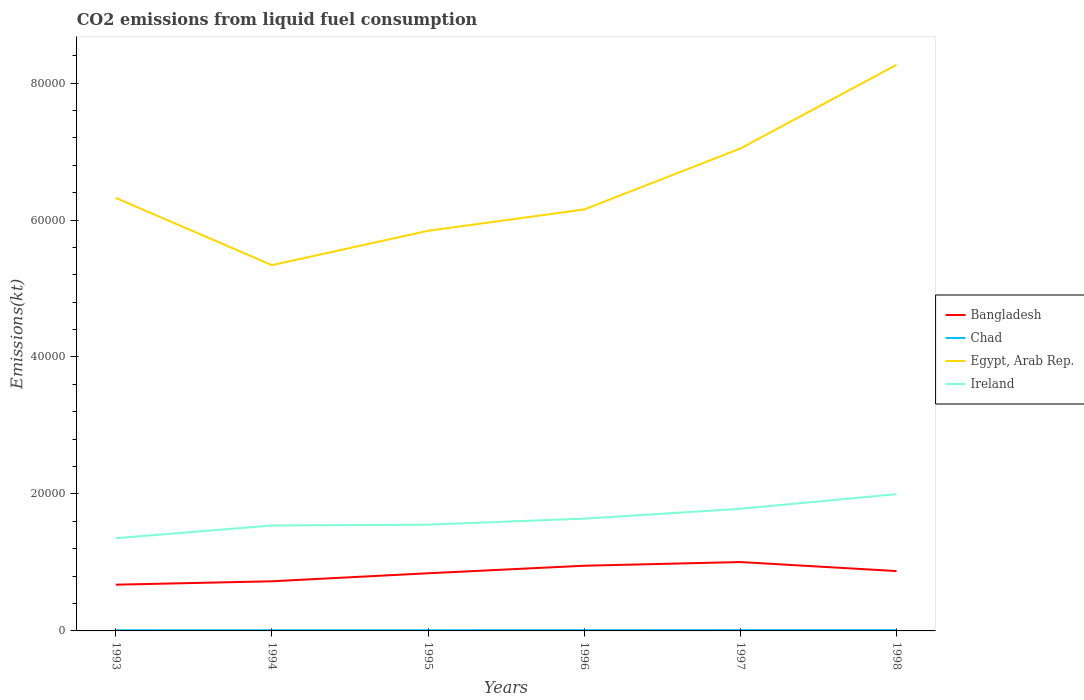How many different coloured lines are there?
Provide a succinct answer. 4. Does the line corresponding to Ireland intersect with the line corresponding to Chad?
Your answer should be compact. No. Across all years, what is the maximum amount of CO2 emitted in Chad?
Give a very brief answer. 99.01. In which year was the amount of CO2 emitted in Ireland maximum?
Offer a very short reply. 1993. What is the total amount of CO2 emitted in Ireland in the graph?
Your answer should be compact. -1001.09. What is the difference between the highest and the second highest amount of CO2 emitted in Ireland?
Make the answer very short. 6431.92. What is the difference between the highest and the lowest amount of CO2 emitted in Ireland?
Provide a short and direct response. 2. Is the amount of CO2 emitted in Chad strictly greater than the amount of CO2 emitted in Egypt, Arab Rep. over the years?
Offer a very short reply. Yes. How many lines are there?
Your response must be concise. 4. What is the difference between two consecutive major ticks on the Y-axis?
Ensure brevity in your answer.  2.00e+04. Does the graph contain any zero values?
Offer a terse response. No. Where does the legend appear in the graph?
Keep it short and to the point. Center right. How many legend labels are there?
Make the answer very short. 4. How are the legend labels stacked?
Make the answer very short. Vertical. What is the title of the graph?
Ensure brevity in your answer.  CO2 emissions from liquid fuel consumption. Does "Nepal" appear as one of the legend labels in the graph?
Provide a succinct answer. No. What is the label or title of the X-axis?
Offer a very short reply. Years. What is the label or title of the Y-axis?
Make the answer very short. Emissions(kt). What is the Emissions(kt) in Bangladesh in 1993?
Ensure brevity in your answer.  6750.95. What is the Emissions(kt) in Chad in 1993?
Provide a short and direct response. 99.01. What is the Emissions(kt) of Egypt, Arab Rep. in 1993?
Provide a short and direct response. 6.32e+04. What is the Emissions(kt) in Ireland in 1993?
Offer a very short reply. 1.35e+04. What is the Emissions(kt) of Bangladesh in 1994?
Give a very brief answer. 7249.66. What is the Emissions(kt) of Chad in 1994?
Provide a short and direct response. 102.68. What is the Emissions(kt) in Egypt, Arab Rep. in 1994?
Make the answer very short. 5.34e+04. What is the Emissions(kt) of Ireland in 1994?
Your response must be concise. 1.54e+04. What is the Emissions(kt) in Bangladesh in 1995?
Your answer should be very brief. 8419.43. What is the Emissions(kt) in Chad in 1995?
Give a very brief answer. 102.68. What is the Emissions(kt) of Egypt, Arab Rep. in 1995?
Your answer should be very brief. 5.84e+04. What is the Emissions(kt) of Ireland in 1995?
Your response must be concise. 1.55e+04. What is the Emissions(kt) in Bangladesh in 1996?
Offer a terse response. 9519.53. What is the Emissions(kt) of Chad in 1996?
Provide a succinct answer. 106.34. What is the Emissions(kt) of Egypt, Arab Rep. in 1996?
Your answer should be compact. 6.15e+04. What is the Emissions(kt) in Ireland in 1996?
Offer a very short reply. 1.64e+04. What is the Emissions(kt) of Bangladesh in 1997?
Keep it short and to the point. 1.01e+04. What is the Emissions(kt) in Chad in 1997?
Offer a very short reply. 113.68. What is the Emissions(kt) in Egypt, Arab Rep. in 1997?
Make the answer very short. 7.04e+04. What is the Emissions(kt) in Ireland in 1997?
Give a very brief answer. 1.78e+04. What is the Emissions(kt) in Bangladesh in 1998?
Offer a very short reply. 8738.46. What is the Emissions(kt) in Chad in 1998?
Give a very brief answer. 113.68. What is the Emissions(kt) in Egypt, Arab Rep. in 1998?
Your answer should be very brief. 8.27e+04. What is the Emissions(kt) in Ireland in 1998?
Offer a very short reply. 2.00e+04. Across all years, what is the maximum Emissions(kt) of Bangladesh?
Provide a short and direct response. 1.01e+04. Across all years, what is the maximum Emissions(kt) of Chad?
Provide a short and direct response. 113.68. Across all years, what is the maximum Emissions(kt) in Egypt, Arab Rep.?
Offer a terse response. 8.27e+04. Across all years, what is the maximum Emissions(kt) in Ireland?
Provide a short and direct response. 2.00e+04. Across all years, what is the minimum Emissions(kt) of Bangladesh?
Your answer should be very brief. 6750.95. Across all years, what is the minimum Emissions(kt) of Chad?
Your answer should be very brief. 99.01. Across all years, what is the minimum Emissions(kt) in Egypt, Arab Rep.?
Make the answer very short. 5.34e+04. Across all years, what is the minimum Emissions(kt) of Ireland?
Keep it short and to the point. 1.35e+04. What is the total Emissions(kt) of Bangladesh in the graph?
Give a very brief answer. 5.07e+04. What is the total Emissions(kt) of Chad in the graph?
Make the answer very short. 638.06. What is the total Emissions(kt) of Egypt, Arab Rep. in the graph?
Make the answer very short. 3.90e+05. What is the total Emissions(kt) in Ireland in the graph?
Keep it short and to the point. 9.86e+04. What is the difference between the Emissions(kt) of Bangladesh in 1993 and that in 1994?
Your response must be concise. -498.71. What is the difference between the Emissions(kt) in Chad in 1993 and that in 1994?
Your response must be concise. -3.67. What is the difference between the Emissions(kt) of Egypt, Arab Rep. in 1993 and that in 1994?
Offer a very short reply. 9820.23. What is the difference between the Emissions(kt) in Ireland in 1993 and that in 1994?
Provide a short and direct response. -1855.5. What is the difference between the Emissions(kt) in Bangladesh in 1993 and that in 1995?
Give a very brief answer. -1668.48. What is the difference between the Emissions(kt) in Chad in 1993 and that in 1995?
Keep it short and to the point. -3.67. What is the difference between the Emissions(kt) of Egypt, Arab Rep. in 1993 and that in 1995?
Ensure brevity in your answer.  4807.44. What is the difference between the Emissions(kt) in Ireland in 1993 and that in 1995?
Provide a succinct answer. -1976.51. What is the difference between the Emissions(kt) of Bangladesh in 1993 and that in 1996?
Your answer should be very brief. -2768.59. What is the difference between the Emissions(kt) of Chad in 1993 and that in 1996?
Your response must be concise. -7.33. What is the difference between the Emissions(kt) of Egypt, Arab Rep. in 1993 and that in 1996?
Your response must be concise. 1690.49. What is the difference between the Emissions(kt) in Ireland in 1993 and that in 1996?
Offer a very short reply. -2856.59. What is the difference between the Emissions(kt) of Bangladesh in 1993 and that in 1997?
Offer a terse response. -3307.63. What is the difference between the Emissions(kt) in Chad in 1993 and that in 1997?
Make the answer very short. -14.67. What is the difference between the Emissions(kt) in Egypt, Arab Rep. in 1993 and that in 1997?
Give a very brief answer. -7205.65. What is the difference between the Emissions(kt) of Ireland in 1993 and that in 1997?
Make the answer very short. -4297.72. What is the difference between the Emissions(kt) in Bangladesh in 1993 and that in 1998?
Offer a terse response. -1987.51. What is the difference between the Emissions(kt) in Chad in 1993 and that in 1998?
Offer a very short reply. -14.67. What is the difference between the Emissions(kt) in Egypt, Arab Rep. in 1993 and that in 1998?
Your answer should be compact. -1.94e+04. What is the difference between the Emissions(kt) of Ireland in 1993 and that in 1998?
Ensure brevity in your answer.  -6431.92. What is the difference between the Emissions(kt) of Bangladesh in 1994 and that in 1995?
Make the answer very short. -1169.77. What is the difference between the Emissions(kt) in Chad in 1994 and that in 1995?
Offer a very short reply. 0. What is the difference between the Emissions(kt) of Egypt, Arab Rep. in 1994 and that in 1995?
Provide a succinct answer. -5012.79. What is the difference between the Emissions(kt) of Ireland in 1994 and that in 1995?
Provide a short and direct response. -121.01. What is the difference between the Emissions(kt) in Bangladesh in 1994 and that in 1996?
Your response must be concise. -2269.87. What is the difference between the Emissions(kt) of Chad in 1994 and that in 1996?
Provide a succinct answer. -3.67. What is the difference between the Emissions(kt) of Egypt, Arab Rep. in 1994 and that in 1996?
Provide a succinct answer. -8129.74. What is the difference between the Emissions(kt) of Ireland in 1994 and that in 1996?
Provide a short and direct response. -1001.09. What is the difference between the Emissions(kt) of Bangladesh in 1994 and that in 1997?
Provide a short and direct response. -2808.92. What is the difference between the Emissions(kt) in Chad in 1994 and that in 1997?
Provide a short and direct response. -11. What is the difference between the Emissions(kt) of Egypt, Arab Rep. in 1994 and that in 1997?
Offer a terse response. -1.70e+04. What is the difference between the Emissions(kt) of Ireland in 1994 and that in 1997?
Give a very brief answer. -2442.22. What is the difference between the Emissions(kt) of Bangladesh in 1994 and that in 1998?
Keep it short and to the point. -1488.8. What is the difference between the Emissions(kt) of Chad in 1994 and that in 1998?
Provide a short and direct response. -11. What is the difference between the Emissions(kt) in Egypt, Arab Rep. in 1994 and that in 1998?
Offer a terse response. -2.92e+04. What is the difference between the Emissions(kt) of Ireland in 1994 and that in 1998?
Your response must be concise. -4576.42. What is the difference between the Emissions(kt) of Bangladesh in 1995 and that in 1996?
Keep it short and to the point. -1100.1. What is the difference between the Emissions(kt) of Chad in 1995 and that in 1996?
Ensure brevity in your answer.  -3.67. What is the difference between the Emissions(kt) of Egypt, Arab Rep. in 1995 and that in 1996?
Ensure brevity in your answer.  -3116.95. What is the difference between the Emissions(kt) in Ireland in 1995 and that in 1996?
Give a very brief answer. -880.08. What is the difference between the Emissions(kt) of Bangladesh in 1995 and that in 1997?
Offer a terse response. -1639.15. What is the difference between the Emissions(kt) in Chad in 1995 and that in 1997?
Your response must be concise. -11. What is the difference between the Emissions(kt) of Egypt, Arab Rep. in 1995 and that in 1997?
Keep it short and to the point. -1.20e+04. What is the difference between the Emissions(kt) of Ireland in 1995 and that in 1997?
Your answer should be very brief. -2321.21. What is the difference between the Emissions(kt) of Bangladesh in 1995 and that in 1998?
Keep it short and to the point. -319.03. What is the difference between the Emissions(kt) of Chad in 1995 and that in 1998?
Keep it short and to the point. -11. What is the difference between the Emissions(kt) in Egypt, Arab Rep. in 1995 and that in 1998?
Ensure brevity in your answer.  -2.42e+04. What is the difference between the Emissions(kt) in Ireland in 1995 and that in 1998?
Provide a short and direct response. -4455.4. What is the difference between the Emissions(kt) in Bangladesh in 1996 and that in 1997?
Your response must be concise. -539.05. What is the difference between the Emissions(kt) of Chad in 1996 and that in 1997?
Your answer should be very brief. -7.33. What is the difference between the Emissions(kt) of Egypt, Arab Rep. in 1996 and that in 1997?
Make the answer very short. -8896.14. What is the difference between the Emissions(kt) in Ireland in 1996 and that in 1997?
Offer a terse response. -1441.13. What is the difference between the Emissions(kt) of Bangladesh in 1996 and that in 1998?
Your answer should be very brief. 781.07. What is the difference between the Emissions(kt) of Chad in 1996 and that in 1998?
Keep it short and to the point. -7.33. What is the difference between the Emissions(kt) of Egypt, Arab Rep. in 1996 and that in 1998?
Offer a very short reply. -2.11e+04. What is the difference between the Emissions(kt) in Ireland in 1996 and that in 1998?
Ensure brevity in your answer.  -3575.32. What is the difference between the Emissions(kt) in Bangladesh in 1997 and that in 1998?
Offer a very short reply. 1320.12. What is the difference between the Emissions(kt) in Chad in 1997 and that in 1998?
Your answer should be compact. 0. What is the difference between the Emissions(kt) of Egypt, Arab Rep. in 1997 and that in 1998?
Keep it short and to the point. -1.22e+04. What is the difference between the Emissions(kt) of Ireland in 1997 and that in 1998?
Offer a terse response. -2134.19. What is the difference between the Emissions(kt) of Bangladesh in 1993 and the Emissions(kt) of Chad in 1994?
Keep it short and to the point. 6648.27. What is the difference between the Emissions(kt) in Bangladesh in 1993 and the Emissions(kt) in Egypt, Arab Rep. in 1994?
Make the answer very short. -4.67e+04. What is the difference between the Emissions(kt) in Bangladesh in 1993 and the Emissions(kt) in Ireland in 1994?
Keep it short and to the point. -8643.12. What is the difference between the Emissions(kt) in Chad in 1993 and the Emissions(kt) in Egypt, Arab Rep. in 1994?
Give a very brief answer. -5.33e+04. What is the difference between the Emissions(kt) of Chad in 1993 and the Emissions(kt) of Ireland in 1994?
Offer a terse response. -1.53e+04. What is the difference between the Emissions(kt) of Egypt, Arab Rep. in 1993 and the Emissions(kt) of Ireland in 1994?
Provide a succinct answer. 4.78e+04. What is the difference between the Emissions(kt) of Bangladesh in 1993 and the Emissions(kt) of Chad in 1995?
Make the answer very short. 6648.27. What is the difference between the Emissions(kt) in Bangladesh in 1993 and the Emissions(kt) in Egypt, Arab Rep. in 1995?
Provide a succinct answer. -5.17e+04. What is the difference between the Emissions(kt) in Bangladesh in 1993 and the Emissions(kt) in Ireland in 1995?
Provide a succinct answer. -8764.13. What is the difference between the Emissions(kt) of Chad in 1993 and the Emissions(kt) of Egypt, Arab Rep. in 1995?
Ensure brevity in your answer.  -5.83e+04. What is the difference between the Emissions(kt) of Chad in 1993 and the Emissions(kt) of Ireland in 1995?
Provide a short and direct response. -1.54e+04. What is the difference between the Emissions(kt) in Egypt, Arab Rep. in 1993 and the Emissions(kt) in Ireland in 1995?
Provide a succinct answer. 4.77e+04. What is the difference between the Emissions(kt) in Bangladesh in 1993 and the Emissions(kt) in Chad in 1996?
Your answer should be compact. 6644.6. What is the difference between the Emissions(kt) of Bangladesh in 1993 and the Emissions(kt) of Egypt, Arab Rep. in 1996?
Your answer should be very brief. -5.48e+04. What is the difference between the Emissions(kt) in Bangladesh in 1993 and the Emissions(kt) in Ireland in 1996?
Keep it short and to the point. -9644.21. What is the difference between the Emissions(kt) in Chad in 1993 and the Emissions(kt) in Egypt, Arab Rep. in 1996?
Keep it short and to the point. -6.14e+04. What is the difference between the Emissions(kt) in Chad in 1993 and the Emissions(kt) in Ireland in 1996?
Ensure brevity in your answer.  -1.63e+04. What is the difference between the Emissions(kt) of Egypt, Arab Rep. in 1993 and the Emissions(kt) of Ireland in 1996?
Ensure brevity in your answer.  4.68e+04. What is the difference between the Emissions(kt) of Bangladesh in 1993 and the Emissions(kt) of Chad in 1997?
Keep it short and to the point. 6637.27. What is the difference between the Emissions(kt) in Bangladesh in 1993 and the Emissions(kt) in Egypt, Arab Rep. in 1997?
Keep it short and to the point. -6.37e+04. What is the difference between the Emissions(kt) of Bangladesh in 1993 and the Emissions(kt) of Ireland in 1997?
Offer a terse response. -1.11e+04. What is the difference between the Emissions(kt) of Chad in 1993 and the Emissions(kt) of Egypt, Arab Rep. in 1997?
Your response must be concise. -7.03e+04. What is the difference between the Emissions(kt) of Chad in 1993 and the Emissions(kt) of Ireland in 1997?
Keep it short and to the point. -1.77e+04. What is the difference between the Emissions(kt) of Egypt, Arab Rep. in 1993 and the Emissions(kt) of Ireland in 1997?
Give a very brief answer. 4.54e+04. What is the difference between the Emissions(kt) in Bangladesh in 1993 and the Emissions(kt) in Chad in 1998?
Provide a short and direct response. 6637.27. What is the difference between the Emissions(kt) in Bangladesh in 1993 and the Emissions(kt) in Egypt, Arab Rep. in 1998?
Offer a terse response. -7.59e+04. What is the difference between the Emissions(kt) of Bangladesh in 1993 and the Emissions(kt) of Ireland in 1998?
Provide a succinct answer. -1.32e+04. What is the difference between the Emissions(kt) in Chad in 1993 and the Emissions(kt) in Egypt, Arab Rep. in 1998?
Provide a succinct answer. -8.26e+04. What is the difference between the Emissions(kt) of Chad in 1993 and the Emissions(kt) of Ireland in 1998?
Provide a short and direct response. -1.99e+04. What is the difference between the Emissions(kt) of Egypt, Arab Rep. in 1993 and the Emissions(kt) of Ireland in 1998?
Make the answer very short. 4.33e+04. What is the difference between the Emissions(kt) of Bangladesh in 1994 and the Emissions(kt) of Chad in 1995?
Provide a succinct answer. 7146.98. What is the difference between the Emissions(kt) of Bangladesh in 1994 and the Emissions(kt) of Egypt, Arab Rep. in 1995?
Offer a very short reply. -5.12e+04. What is the difference between the Emissions(kt) in Bangladesh in 1994 and the Emissions(kt) in Ireland in 1995?
Your response must be concise. -8265.42. What is the difference between the Emissions(kt) in Chad in 1994 and the Emissions(kt) in Egypt, Arab Rep. in 1995?
Keep it short and to the point. -5.83e+04. What is the difference between the Emissions(kt) of Chad in 1994 and the Emissions(kt) of Ireland in 1995?
Provide a short and direct response. -1.54e+04. What is the difference between the Emissions(kt) of Egypt, Arab Rep. in 1994 and the Emissions(kt) of Ireland in 1995?
Offer a very short reply. 3.79e+04. What is the difference between the Emissions(kt) of Bangladesh in 1994 and the Emissions(kt) of Chad in 1996?
Your response must be concise. 7143.32. What is the difference between the Emissions(kt) in Bangladesh in 1994 and the Emissions(kt) in Egypt, Arab Rep. in 1996?
Keep it short and to the point. -5.43e+04. What is the difference between the Emissions(kt) in Bangladesh in 1994 and the Emissions(kt) in Ireland in 1996?
Your response must be concise. -9145.5. What is the difference between the Emissions(kt) of Chad in 1994 and the Emissions(kt) of Egypt, Arab Rep. in 1996?
Provide a short and direct response. -6.14e+04. What is the difference between the Emissions(kt) in Chad in 1994 and the Emissions(kt) in Ireland in 1996?
Make the answer very short. -1.63e+04. What is the difference between the Emissions(kt) in Egypt, Arab Rep. in 1994 and the Emissions(kt) in Ireland in 1996?
Make the answer very short. 3.70e+04. What is the difference between the Emissions(kt) in Bangladesh in 1994 and the Emissions(kt) in Chad in 1997?
Make the answer very short. 7135.98. What is the difference between the Emissions(kt) in Bangladesh in 1994 and the Emissions(kt) in Egypt, Arab Rep. in 1997?
Keep it short and to the point. -6.32e+04. What is the difference between the Emissions(kt) in Bangladesh in 1994 and the Emissions(kt) in Ireland in 1997?
Ensure brevity in your answer.  -1.06e+04. What is the difference between the Emissions(kt) in Chad in 1994 and the Emissions(kt) in Egypt, Arab Rep. in 1997?
Give a very brief answer. -7.03e+04. What is the difference between the Emissions(kt) in Chad in 1994 and the Emissions(kt) in Ireland in 1997?
Your answer should be compact. -1.77e+04. What is the difference between the Emissions(kt) of Egypt, Arab Rep. in 1994 and the Emissions(kt) of Ireland in 1997?
Your response must be concise. 3.56e+04. What is the difference between the Emissions(kt) of Bangladesh in 1994 and the Emissions(kt) of Chad in 1998?
Your answer should be very brief. 7135.98. What is the difference between the Emissions(kt) in Bangladesh in 1994 and the Emissions(kt) in Egypt, Arab Rep. in 1998?
Provide a short and direct response. -7.54e+04. What is the difference between the Emissions(kt) of Bangladesh in 1994 and the Emissions(kt) of Ireland in 1998?
Keep it short and to the point. -1.27e+04. What is the difference between the Emissions(kt) of Chad in 1994 and the Emissions(kt) of Egypt, Arab Rep. in 1998?
Your answer should be compact. -8.26e+04. What is the difference between the Emissions(kt) of Chad in 1994 and the Emissions(kt) of Ireland in 1998?
Offer a terse response. -1.99e+04. What is the difference between the Emissions(kt) of Egypt, Arab Rep. in 1994 and the Emissions(kt) of Ireland in 1998?
Provide a succinct answer. 3.34e+04. What is the difference between the Emissions(kt) of Bangladesh in 1995 and the Emissions(kt) of Chad in 1996?
Give a very brief answer. 8313.09. What is the difference between the Emissions(kt) in Bangladesh in 1995 and the Emissions(kt) in Egypt, Arab Rep. in 1996?
Ensure brevity in your answer.  -5.31e+04. What is the difference between the Emissions(kt) in Bangladesh in 1995 and the Emissions(kt) in Ireland in 1996?
Ensure brevity in your answer.  -7975.73. What is the difference between the Emissions(kt) in Chad in 1995 and the Emissions(kt) in Egypt, Arab Rep. in 1996?
Give a very brief answer. -6.14e+04. What is the difference between the Emissions(kt) of Chad in 1995 and the Emissions(kt) of Ireland in 1996?
Give a very brief answer. -1.63e+04. What is the difference between the Emissions(kt) in Egypt, Arab Rep. in 1995 and the Emissions(kt) in Ireland in 1996?
Provide a succinct answer. 4.20e+04. What is the difference between the Emissions(kt) in Bangladesh in 1995 and the Emissions(kt) in Chad in 1997?
Make the answer very short. 8305.75. What is the difference between the Emissions(kt) in Bangladesh in 1995 and the Emissions(kt) in Egypt, Arab Rep. in 1997?
Keep it short and to the point. -6.20e+04. What is the difference between the Emissions(kt) in Bangladesh in 1995 and the Emissions(kt) in Ireland in 1997?
Offer a terse response. -9416.86. What is the difference between the Emissions(kt) in Chad in 1995 and the Emissions(kt) in Egypt, Arab Rep. in 1997?
Ensure brevity in your answer.  -7.03e+04. What is the difference between the Emissions(kt) in Chad in 1995 and the Emissions(kt) in Ireland in 1997?
Give a very brief answer. -1.77e+04. What is the difference between the Emissions(kt) in Egypt, Arab Rep. in 1995 and the Emissions(kt) in Ireland in 1997?
Provide a succinct answer. 4.06e+04. What is the difference between the Emissions(kt) of Bangladesh in 1995 and the Emissions(kt) of Chad in 1998?
Provide a short and direct response. 8305.75. What is the difference between the Emissions(kt) in Bangladesh in 1995 and the Emissions(kt) in Egypt, Arab Rep. in 1998?
Offer a terse response. -7.42e+04. What is the difference between the Emissions(kt) in Bangladesh in 1995 and the Emissions(kt) in Ireland in 1998?
Your answer should be compact. -1.16e+04. What is the difference between the Emissions(kt) in Chad in 1995 and the Emissions(kt) in Egypt, Arab Rep. in 1998?
Your answer should be very brief. -8.26e+04. What is the difference between the Emissions(kt) of Chad in 1995 and the Emissions(kt) of Ireland in 1998?
Your answer should be compact. -1.99e+04. What is the difference between the Emissions(kt) of Egypt, Arab Rep. in 1995 and the Emissions(kt) of Ireland in 1998?
Ensure brevity in your answer.  3.85e+04. What is the difference between the Emissions(kt) in Bangladesh in 1996 and the Emissions(kt) in Chad in 1997?
Keep it short and to the point. 9405.85. What is the difference between the Emissions(kt) in Bangladesh in 1996 and the Emissions(kt) in Egypt, Arab Rep. in 1997?
Offer a terse response. -6.09e+04. What is the difference between the Emissions(kt) in Bangladesh in 1996 and the Emissions(kt) in Ireland in 1997?
Give a very brief answer. -8316.76. What is the difference between the Emissions(kt) in Chad in 1996 and the Emissions(kt) in Egypt, Arab Rep. in 1997?
Ensure brevity in your answer.  -7.03e+04. What is the difference between the Emissions(kt) of Chad in 1996 and the Emissions(kt) of Ireland in 1997?
Give a very brief answer. -1.77e+04. What is the difference between the Emissions(kt) of Egypt, Arab Rep. in 1996 and the Emissions(kt) of Ireland in 1997?
Your response must be concise. 4.37e+04. What is the difference between the Emissions(kt) in Bangladesh in 1996 and the Emissions(kt) in Chad in 1998?
Make the answer very short. 9405.85. What is the difference between the Emissions(kt) in Bangladesh in 1996 and the Emissions(kt) in Egypt, Arab Rep. in 1998?
Offer a very short reply. -7.31e+04. What is the difference between the Emissions(kt) of Bangladesh in 1996 and the Emissions(kt) of Ireland in 1998?
Give a very brief answer. -1.05e+04. What is the difference between the Emissions(kt) in Chad in 1996 and the Emissions(kt) in Egypt, Arab Rep. in 1998?
Keep it short and to the point. -8.26e+04. What is the difference between the Emissions(kt) in Chad in 1996 and the Emissions(kt) in Ireland in 1998?
Your answer should be compact. -1.99e+04. What is the difference between the Emissions(kt) in Egypt, Arab Rep. in 1996 and the Emissions(kt) in Ireland in 1998?
Provide a short and direct response. 4.16e+04. What is the difference between the Emissions(kt) in Bangladesh in 1997 and the Emissions(kt) in Chad in 1998?
Give a very brief answer. 9944.9. What is the difference between the Emissions(kt) of Bangladesh in 1997 and the Emissions(kt) of Egypt, Arab Rep. in 1998?
Provide a succinct answer. -7.26e+04. What is the difference between the Emissions(kt) in Bangladesh in 1997 and the Emissions(kt) in Ireland in 1998?
Your answer should be very brief. -9911.9. What is the difference between the Emissions(kt) in Chad in 1997 and the Emissions(kt) in Egypt, Arab Rep. in 1998?
Provide a short and direct response. -8.25e+04. What is the difference between the Emissions(kt) in Chad in 1997 and the Emissions(kt) in Ireland in 1998?
Your answer should be compact. -1.99e+04. What is the difference between the Emissions(kt) of Egypt, Arab Rep. in 1997 and the Emissions(kt) of Ireland in 1998?
Provide a short and direct response. 5.05e+04. What is the average Emissions(kt) of Bangladesh per year?
Provide a succinct answer. 8456.1. What is the average Emissions(kt) of Chad per year?
Provide a succinct answer. 106.34. What is the average Emissions(kt) of Egypt, Arab Rep. per year?
Provide a succinct answer. 6.50e+04. What is the average Emissions(kt) of Ireland per year?
Your response must be concise. 1.64e+04. In the year 1993, what is the difference between the Emissions(kt) of Bangladesh and Emissions(kt) of Chad?
Your response must be concise. 6651.94. In the year 1993, what is the difference between the Emissions(kt) in Bangladesh and Emissions(kt) in Egypt, Arab Rep.?
Your response must be concise. -5.65e+04. In the year 1993, what is the difference between the Emissions(kt) in Bangladesh and Emissions(kt) in Ireland?
Your response must be concise. -6787.62. In the year 1993, what is the difference between the Emissions(kt) of Chad and Emissions(kt) of Egypt, Arab Rep.?
Your answer should be compact. -6.31e+04. In the year 1993, what is the difference between the Emissions(kt) in Chad and Emissions(kt) in Ireland?
Your answer should be very brief. -1.34e+04. In the year 1993, what is the difference between the Emissions(kt) in Egypt, Arab Rep. and Emissions(kt) in Ireland?
Offer a very short reply. 4.97e+04. In the year 1994, what is the difference between the Emissions(kt) of Bangladesh and Emissions(kt) of Chad?
Offer a terse response. 7146.98. In the year 1994, what is the difference between the Emissions(kt) in Bangladesh and Emissions(kt) in Egypt, Arab Rep.?
Give a very brief answer. -4.62e+04. In the year 1994, what is the difference between the Emissions(kt) in Bangladesh and Emissions(kt) in Ireland?
Your answer should be very brief. -8144.41. In the year 1994, what is the difference between the Emissions(kt) of Chad and Emissions(kt) of Egypt, Arab Rep.?
Offer a terse response. -5.33e+04. In the year 1994, what is the difference between the Emissions(kt) of Chad and Emissions(kt) of Ireland?
Your answer should be compact. -1.53e+04. In the year 1994, what is the difference between the Emissions(kt) in Egypt, Arab Rep. and Emissions(kt) in Ireland?
Offer a terse response. 3.80e+04. In the year 1995, what is the difference between the Emissions(kt) of Bangladesh and Emissions(kt) of Chad?
Offer a very short reply. 8316.76. In the year 1995, what is the difference between the Emissions(kt) of Bangladesh and Emissions(kt) of Egypt, Arab Rep.?
Provide a short and direct response. -5.00e+04. In the year 1995, what is the difference between the Emissions(kt) of Bangladesh and Emissions(kt) of Ireland?
Your answer should be compact. -7095.65. In the year 1995, what is the difference between the Emissions(kt) in Chad and Emissions(kt) in Egypt, Arab Rep.?
Keep it short and to the point. -5.83e+04. In the year 1995, what is the difference between the Emissions(kt) in Chad and Emissions(kt) in Ireland?
Your answer should be very brief. -1.54e+04. In the year 1995, what is the difference between the Emissions(kt) in Egypt, Arab Rep. and Emissions(kt) in Ireland?
Provide a succinct answer. 4.29e+04. In the year 1996, what is the difference between the Emissions(kt) of Bangladesh and Emissions(kt) of Chad?
Offer a terse response. 9413.19. In the year 1996, what is the difference between the Emissions(kt) in Bangladesh and Emissions(kt) in Egypt, Arab Rep.?
Give a very brief answer. -5.20e+04. In the year 1996, what is the difference between the Emissions(kt) in Bangladesh and Emissions(kt) in Ireland?
Make the answer very short. -6875.62. In the year 1996, what is the difference between the Emissions(kt) in Chad and Emissions(kt) in Egypt, Arab Rep.?
Offer a very short reply. -6.14e+04. In the year 1996, what is the difference between the Emissions(kt) of Chad and Emissions(kt) of Ireland?
Your answer should be compact. -1.63e+04. In the year 1996, what is the difference between the Emissions(kt) of Egypt, Arab Rep. and Emissions(kt) of Ireland?
Offer a very short reply. 4.51e+04. In the year 1997, what is the difference between the Emissions(kt) of Bangladesh and Emissions(kt) of Chad?
Offer a terse response. 9944.9. In the year 1997, what is the difference between the Emissions(kt) in Bangladesh and Emissions(kt) in Egypt, Arab Rep.?
Offer a terse response. -6.04e+04. In the year 1997, what is the difference between the Emissions(kt) of Bangladesh and Emissions(kt) of Ireland?
Your answer should be compact. -7777.71. In the year 1997, what is the difference between the Emissions(kt) of Chad and Emissions(kt) of Egypt, Arab Rep.?
Your answer should be very brief. -7.03e+04. In the year 1997, what is the difference between the Emissions(kt) in Chad and Emissions(kt) in Ireland?
Ensure brevity in your answer.  -1.77e+04. In the year 1997, what is the difference between the Emissions(kt) of Egypt, Arab Rep. and Emissions(kt) of Ireland?
Offer a terse response. 5.26e+04. In the year 1998, what is the difference between the Emissions(kt) in Bangladesh and Emissions(kt) in Chad?
Your response must be concise. 8624.78. In the year 1998, what is the difference between the Emissions(kt) in Bangladesh and Emissions(kt) in Egypt, Arab Rep.?
Your answer should be very brief. -7.39e+04. In the year 1998, what is the difference between the Emissions(kt) in Bangladesh and Emissions(kt) in Ireland?
Your answer should be compact. -1.12e+04. In the year 1998, what is the difference between the Emissions(kt) in Chad and Emissions(kt) in Egypt, Arab Rep.?
Provide a short and direct response. -8.25e+04. In the year 1998, what is the difference between the Emissions(kt) in Chad and Emissions(kt) in Ireland?
Keep it short and to the point. -1.99e+04. In the year 1998, what is the difference between the Emissions(kt) in Egypt, Arab Rep. and Emissions(kt) in Ireland?
Provide a succinct answer. 6.27e+04. What is the ratio of the Emissions(kt) in Bangladesh in 1993 to that in 1994?
Provide a short and direct response. 0.93. What is the ratio of the Emissions(kt) of Chad in 1993 to that in 1994?
Make the answer very short. 0.96. What is the ratio of the Emissions(kt) in Egypt, Arab Rep. in 1993 to that in 1994?
Your response must be concise. 1.18. What is the ratio of the Emissions(kt) in Ireland in 1993 to that in 1994?
Offer a very short reply. 0.88. What is the ratio of the Emissions(kt) of Bangladesh in 1993 to that in 1995?
Offer a very short reply. 0.8. What is the ratio of the Emissions(kt) in Chad in 1993 to that in 1995?
Make the answer very short. 0.96. What is the ratio of the Emissions(kt) in Egypt, Arab Rep. in 1993 to that in 1995?
Offer a very short reply. 1.08. What is the ratio of the Emissions(kt) in Ireland in 1993 to that in 1995?
Make the answer very short. 0.87. What is the ratio of the Emissions(kt) in Bangladesh in 1993 to that in 1996?
Offer a terse response. 0.71. What is the ratio of the Emissions(kt) of Chad in 1993 to that in 1996?
Ensure brevity in your answer.  0.93. What is the ratio of the Emissions(kt) of Egypt, Arab Rep. in 1993 to that in 1996?
Your response must be concise. 1.03. What is the ratio of the Emissions(kt) of Ireland in 1993 to that in 1996?
Provide a succinct answer. 0.83. What is the ratio of the Emissions(kt) in Bangladesh in 1993 to that in 1997?
Provide a short and direct response. 0.67. What is the ratio of the Emissions(kt) of Chad in 1993 to that in 1997?
Make the answer very short. 0.87. What is the ratio of the Emissions(kt) of Egypt, Arab Rep. in 1993 to that in 1997?
Give a very brief answer. 0.9. What is the ratio of the Emissions(kt) in Ireland in 1993 to that in 1997?
Make the answer very short. 0.76. What is the ratio of the Emissions(kt) in Bangladesh in 1993 to that in 1998?
Give a very brief answer. 0.77. What is the ratio of the Emissions(kt) of Chad in 1993 to that in 1998?
Give a very brief answer. 0.87. What is the ratio of the Emissions(kt) in Egypt, Arab Rep. in 1993 to that in 1998?
Give a very brief answer. 0.77. What is the ratio of the Emissions(kt) of Ireland in 1993 to that in 1998?
Your answer should be compact. 0.68. What is the ratio of the Emissions(kt) of Bangladesh in 1994 to that in 1995?
Offer a terse response. 0.86. What is the ratio of the Emissions(kt) of Chad in 1994 to that in 1995?
Ensure brevity in your answer.  1. What is the ratio of the Emissions(kt) of Egypt, Arab Rep. in 1994 to that in 1995?
Offer a terse response. 0.91. What is the ratio of the Emissions(kt) in Ireland in 1994 to that in 1995?
Your response must be concise. 0.99. What is the ratio of the Emissions(kt) in Bangladesh in 1994 to that in 1996?
Ensure brevity in your answer.  0.76. What is the ratio of the Emissions(kt) in Chad in 1994 to that in 1996?
Offer a terse response. 0.97. What is the ratio of the Emissions(kt) of Egypt, Arab Rep. in 1994 to that in 1996?
Give a very brief answer. 0.87. What is the ratio of the Emissions(kt) in Ireland in 1994 to that in 1996?
Keep it short and to the point. 0.94. What is the ratio of the Emissions(kt) of Bangladesh in 1994 to that in 1997?
Ensure brevity in your answer.  0.72. What is the ratio of the Emissions(kt) of Chad in 1994 to that in 1997?
Your answer should be very brief. 0.9. What is the ratio of the Emissions(kt) in Egypt, Arab Rep. in 1994 to that in 1997?
Offer a very short reply. 0.76. What is the ratio of the Emissions(kt) of Ireland in 1994 to that in 1997?
Your answer should be very brief. 0.86. What is the ratio of the Emissions(kt) of Bangladesh in 1994 to that in 1998?
Your response must be concise. 0.83. What is the ratio of the Emissions(kt) of Chad in 1994 to that in 1998?
Provide a short and direct response. 0.9. What is the ratio of the Emissions(kt) of Egypt, Arab Rep. in 1994 to that in 1998?
Your response must be concise. 0.65. What is the ratio of the Emissions(kt) of Ireland in 1994 to that in 1998?
Your response must be concise. 0.77. What is the ratio of the Emissions(kt) of Bangladesh in 1995 to that in 1996?
Give a very brief answer. 0.88. What is the ratio of the Emissions(kt) of Chad in 1995 to that in 1996?
Provide a succinct answer. 0.97. What is the ratio of the Emissions(kt) of Egypt, Arab Rep. in 1995 to that in 1996?
Your response must be concise. 0.95. What is the ratio of the Emissions(kt) of Ireland in 1995 to that in 1996?
Your answer should be compact. 0.95. What is the ratio of the Emissions(kt) in Bangladesh in 1995 to that in 1997?
Ensure brevity in your answer.  0.84. What is the ratio of the Emissions(kt) of Chad in 1995 to that in 1997?
Your response must be concise. 0.9. What is the ratio of the Emissions(kt) of Egypt, Arab Rep. in 1995 to that in 1997?
Your response must be concise. 0.83. What is the ratio of the Emissions(kt) in Ireland in 1995 to that in 1997?
Keep it short and to the point. 0.87. What is the ratio of the Emissions(kt) of Bangladesh in 1995 to that in 1998?
Make the answer very short. 0.96. What is the ratio of the Emissions(kt) of Chad in 1995 to that in 1998?
Offer a very short reply. 0.9. What is the ratio of the Emissions(kt) in Egypt, Arab Rep. in 1995 to that in 1998?
Give a very brief answer. 0.71. What is the ratio of the Emissions(kt) in Ireland in 1995 to that in 1998?
Your answer should be very brief. 0.78. What is the ratio of the Emissions(kt) of Bangladesh in 1996 to that in 1997?
Your answer should be very brief. 0.95. What is the ratio of the Emissions(kt) in Chad in 1996 to that in 1997?
Offer a very short reply. 0.94. What is the ratio of the Emissions(kt) in Egypt, Arab Rep. in 1996 to that in 1997?
Offer a very short reply. 0.87. What is the ratio of the Emissions(kt) of Ireland in 1996 to that in 1997?
Your response must be concise. 0.92. What is the ratio of the Emissions(kt) in Bangladesh in 1996 to that in 1998?
Your answer should be very brief. 1.09. What is the ratio of the Emissions(kt) of Chad in 1996 to that in 1998?
Provide a succinct answer. 0.94. What is the ratio of the Emissions(kt) in Egypt, Arab Rep. in 1996 to that in 1998?
Keep it short and to the point. 0.74. What is the ratio of the Emissions(kt) in Ireland in 1996 to that in 1998?
Give a very brief answer. 0.82. What is the ratio of the Emissions(kt) of Bangladesh in 1997 to that in 1998?
Give a very brief answer. 1.15. What is the ratio of the Emissions(kt) in Chad in 1997 to that in 1998?
Give a very brief answer. 1. What is the ratio of the Emissions(kt) in Egypt, Arab Rep. in 1997 to that in 1998?
Provide a short and direct response. 0.85. What is the ratio of the Emissions(kt) of Ireland in 1997 to that in 1998?
Provide a short and direct response. 0.89. What is the difference between the highest and the second highest Emissions(kt) of Bangladesh?
Offer a very short reply. 539.05. What is the difference between the highest and the second highest Emissions(kt) of Chad?
Your answer should be compact. 0. What is the difference between the highest and the second highest Emissions(kt) in Egypt, Arab Rep.?
Keep it short and to the point. 1.22e+04. What is the difference between the highest and the second highest Emissions(kt) of Ireland?
Keep it short and to the point. 2134.19. What is the difference between the highest and the lowest Emissions(kt) of Bangladesh?
Give a very brief answer. 3307.63. What is the difference between the highest and the lowest Emissions(kt) in Chad?
Offer a terse response. 14.67. What is the difference between the highest and the lowest Emissions(kt) in Egypt, Arab Rep.?
Offer a terse response. 2.92e+04. What is the difference between the highest and the lowest Emissions(kt) in Ireland?
Make the answer very short. 6431.92. 